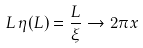Convert formula to latex. <formula><loc_0><loc_0><loc_500><loc_500>L \, \eta ( L ) = \frac { L } { \xi } \rightarrow 2 \pi x</formula> 